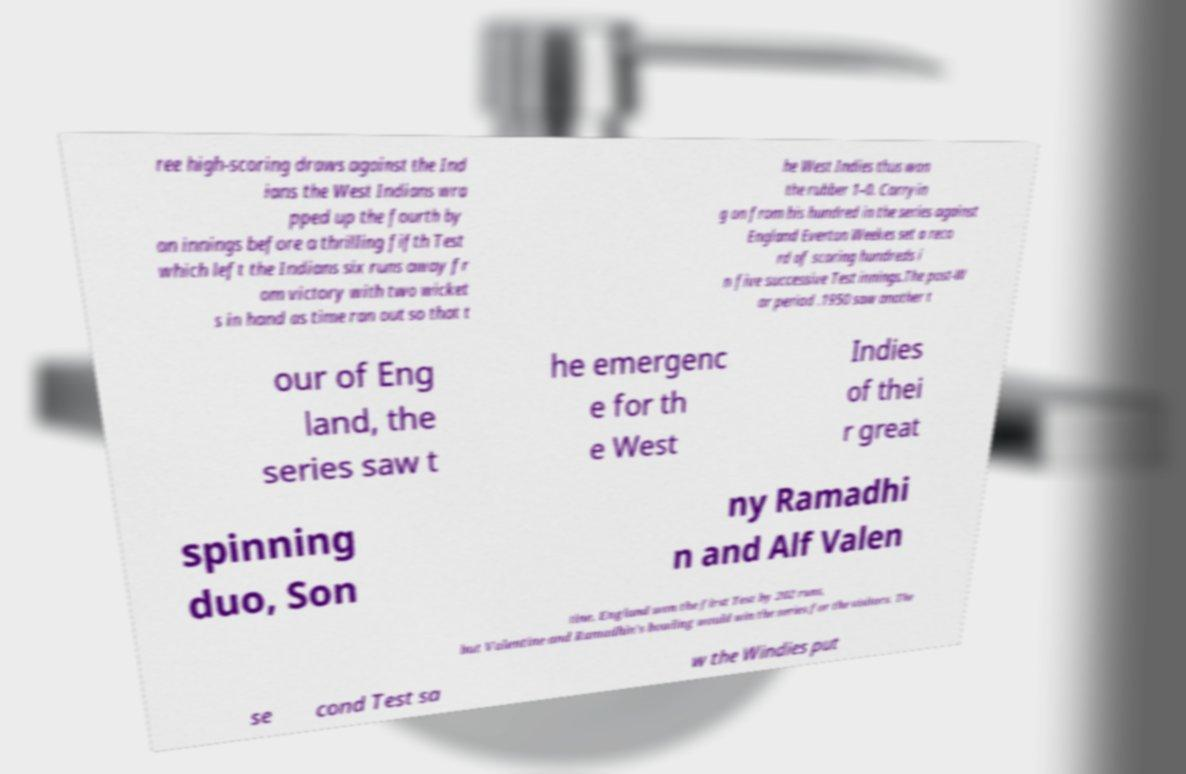Please read and relay the text visible in this image. What does it say? ree high-scoring draws against the Ind ians the West Indians wra pped up the fourth by an innings before a thrilling fifth Test which left the Indians six runs away fr om victory with two wicket s in hand as time ran out so that t he West Indies thus won the rubber 1–0. Carryin g on from his hundred in the series against England Everton Weekes set a reco rd of scoring hundreds i n five successive Test innings.The post-W ar period .1950 saw another t our of Eng land, the series saw t he emergenc e for th e West Indies of thei r great spinning duo, Son ny Ramadhi n and Alf Valen tine. England won the first Test by 202 runs, but Valentine and Ramadhin's bowling would win the series for the visitors. The se cond Test sa w the Windies put 